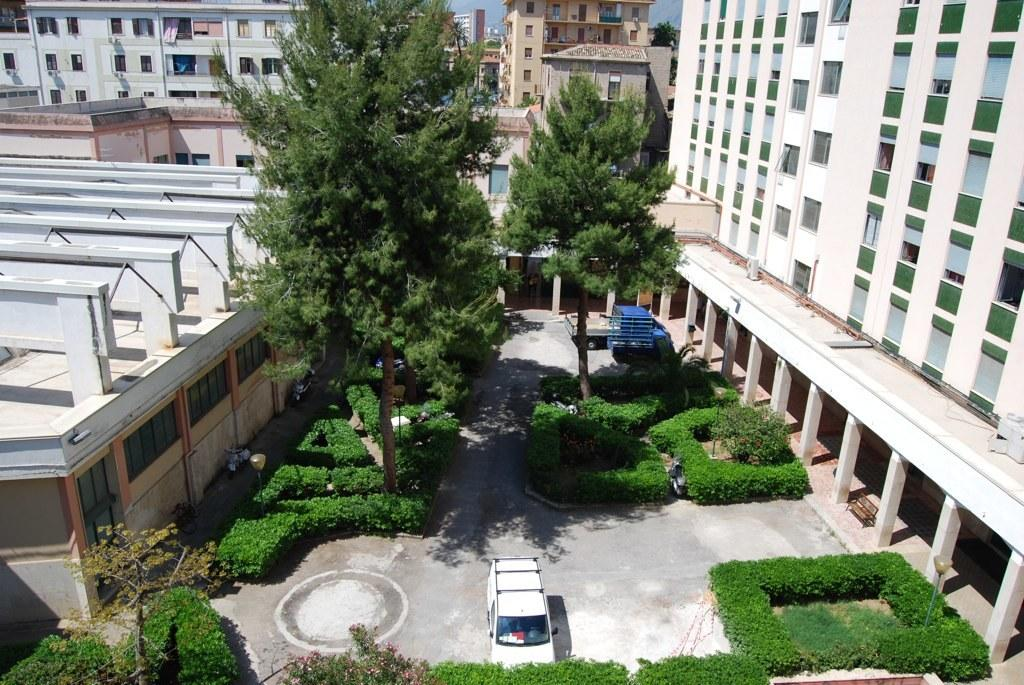What type of structures can be seen in the image? There are buildings in the image. What natural elements are present in the image? There are trees and plants in the image. What man-made objects can be seen on the ground in the image? There are vehicles on the ground in the image. What else can be seen in the image besides the mentioned elements? There are other objects in the image. What is visible in the background of the image? The sky is visible in the background of the image. Can you describe the ocean waves in the image? There is no ocean or waves present in the image; it features buildings, trees, plants, vehicles, and other objects. What type of art is displayed on the buildings in the image? There is no art displayed on the buildings in the image; the focus is on the structures themselves and the surrounding environment. 